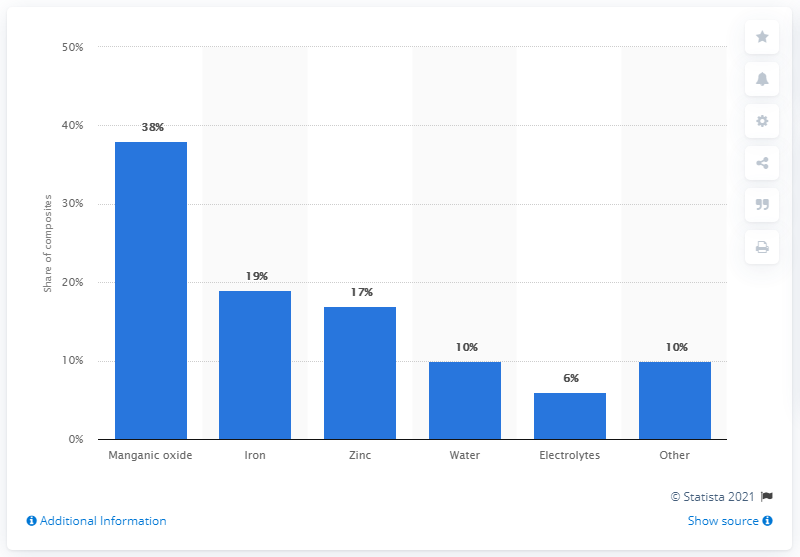Outline some significant characteristics in this image. According to available data, approximately 60% of an alkaline manganese battery is comprised of electrolytes. 